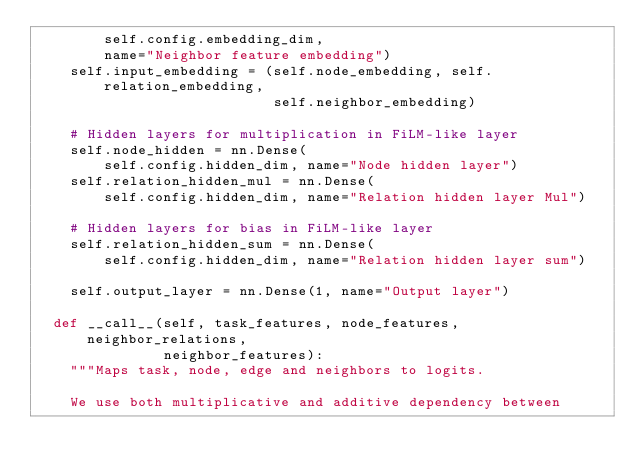<code> <loc_0><loc_0><loc_500><loc_500><_Python_>        self.config.embedding_dim,
        name="Neighbor feature embedding")
    self.input_embedding = (self.node_embedding, self.relation_embedding,
                            self.neighbor_embedding)

    # Hidden layers for multiplication in FiLM-like layer
    self.node_hidden = nn.Dense(
        self.config.hidden_dim, name="Node hidden layer")
    self.relation_hidden_mul = nn.Dense(
        self.config.hidden_dim, name="Relation hidden layer Mul")

    # Hidden layers for bias in FiLM-like layer
    self.relation_hidden_sum = nn.Dense(
        self.config.hidden_dim, name="Relation hidden layer sum")

    self.output_layer = nn.Dense(1, name="Output layer")

  def __call__(self, task_features, node_features, neighbor_relations,
               neighbor_features):
    """Maps task, node, edge and neighbors to logits.

    We use both multiplicative and additive dependency between</code> 